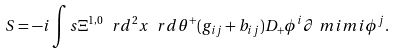<formula> <loc_0><loc_0><loc_500><loc_500>S = - i \int s { \Xi ^ { 1 , 0 } } { \ r d ^ { 2 } x \ r d \theta ^ { + } } ( g _ { i j } + b _ { i j } ) D _ { + } \phi ^ { i } \partial _ { \ } m i m i \phi ^ { j } .</formula> 